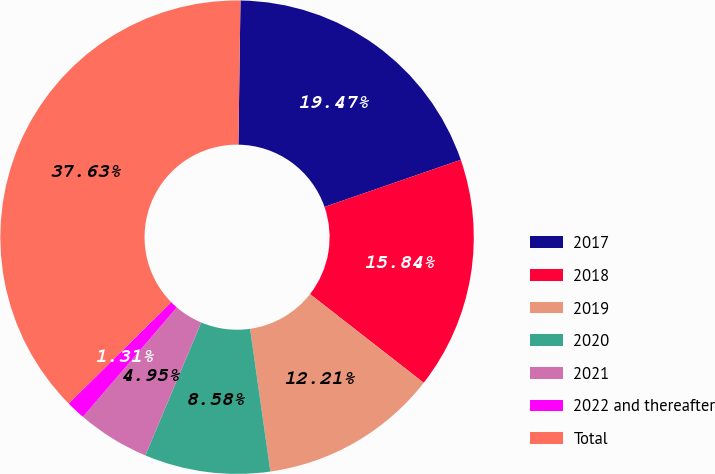Convert chart. <chart><loc_0><loc_0><loc_500><loc_500><pie_chart><fcel>2017<fcel>2018<fcel>2019<fcel>2020<fcel>2021<fcel>2022 and thereafter<fcel>Total<nl><fcel>19.47%<fcel>15.84%<fcel>12.21%<fcel>8.58%<fcel>4.95%<fcel>1.31%<fcel>37.63%<nl></chart> 